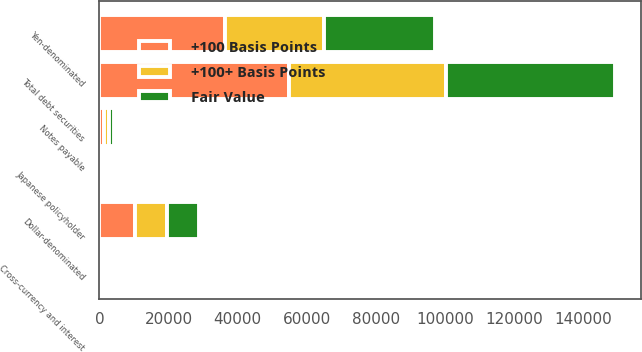<chart> <loc_0><loc_0><loc_500><loc_500><stacked_bar_chart><ecel><fcel>Yen-denominated<fcel>Dollar-denominated<fcel>Total debt securities<fcel>Notes payable<fcel>Cross-currency and interest<fcel>Japanese policyholder<nl><fcel>+100 Basis Points<fcel>36314<fcel>10388<fcel>54731<fcel>1452<fcel>35<fcel>151<nl><fcel>Fair Value<fcel>32151<fcel>9505<fcel>48940<fcel>1415<fcel>27<fcel>151<nl><fcel>+100+ Basis Points<fcel>28712<fcel>9033<fcel>45363<fcel>1386<fcel>5<fcel>175<nl></chart> 